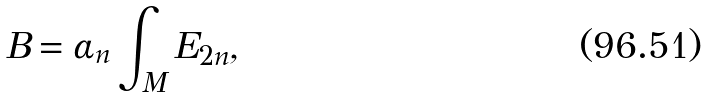Convert formula to latex. <formula><loc_0><loc_0><loc_500><loc_500>B = \alpha _ { n } \int _ { M } E _ { 2 n } ,</formula> 